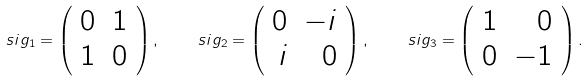Convert formula to latex. <formula><loc_0><loc_0><loc_500><loc_500>\ s i g _ { 1 } = \left ( \begin{array} { r r } 0 & 1 \\ 1 & 0 \end{array} \right ) , \quad \ s i g _ { 2 } = \left ( \begin{array} { r r } 0 & - i \\ i & 0 \end{array} \right ) , \quad \ s i g _ { 3 } = \left ( \begin{array} { r r } 1 & 0 \\ 0 & - 1 \end{array} \right ) .</formula> 